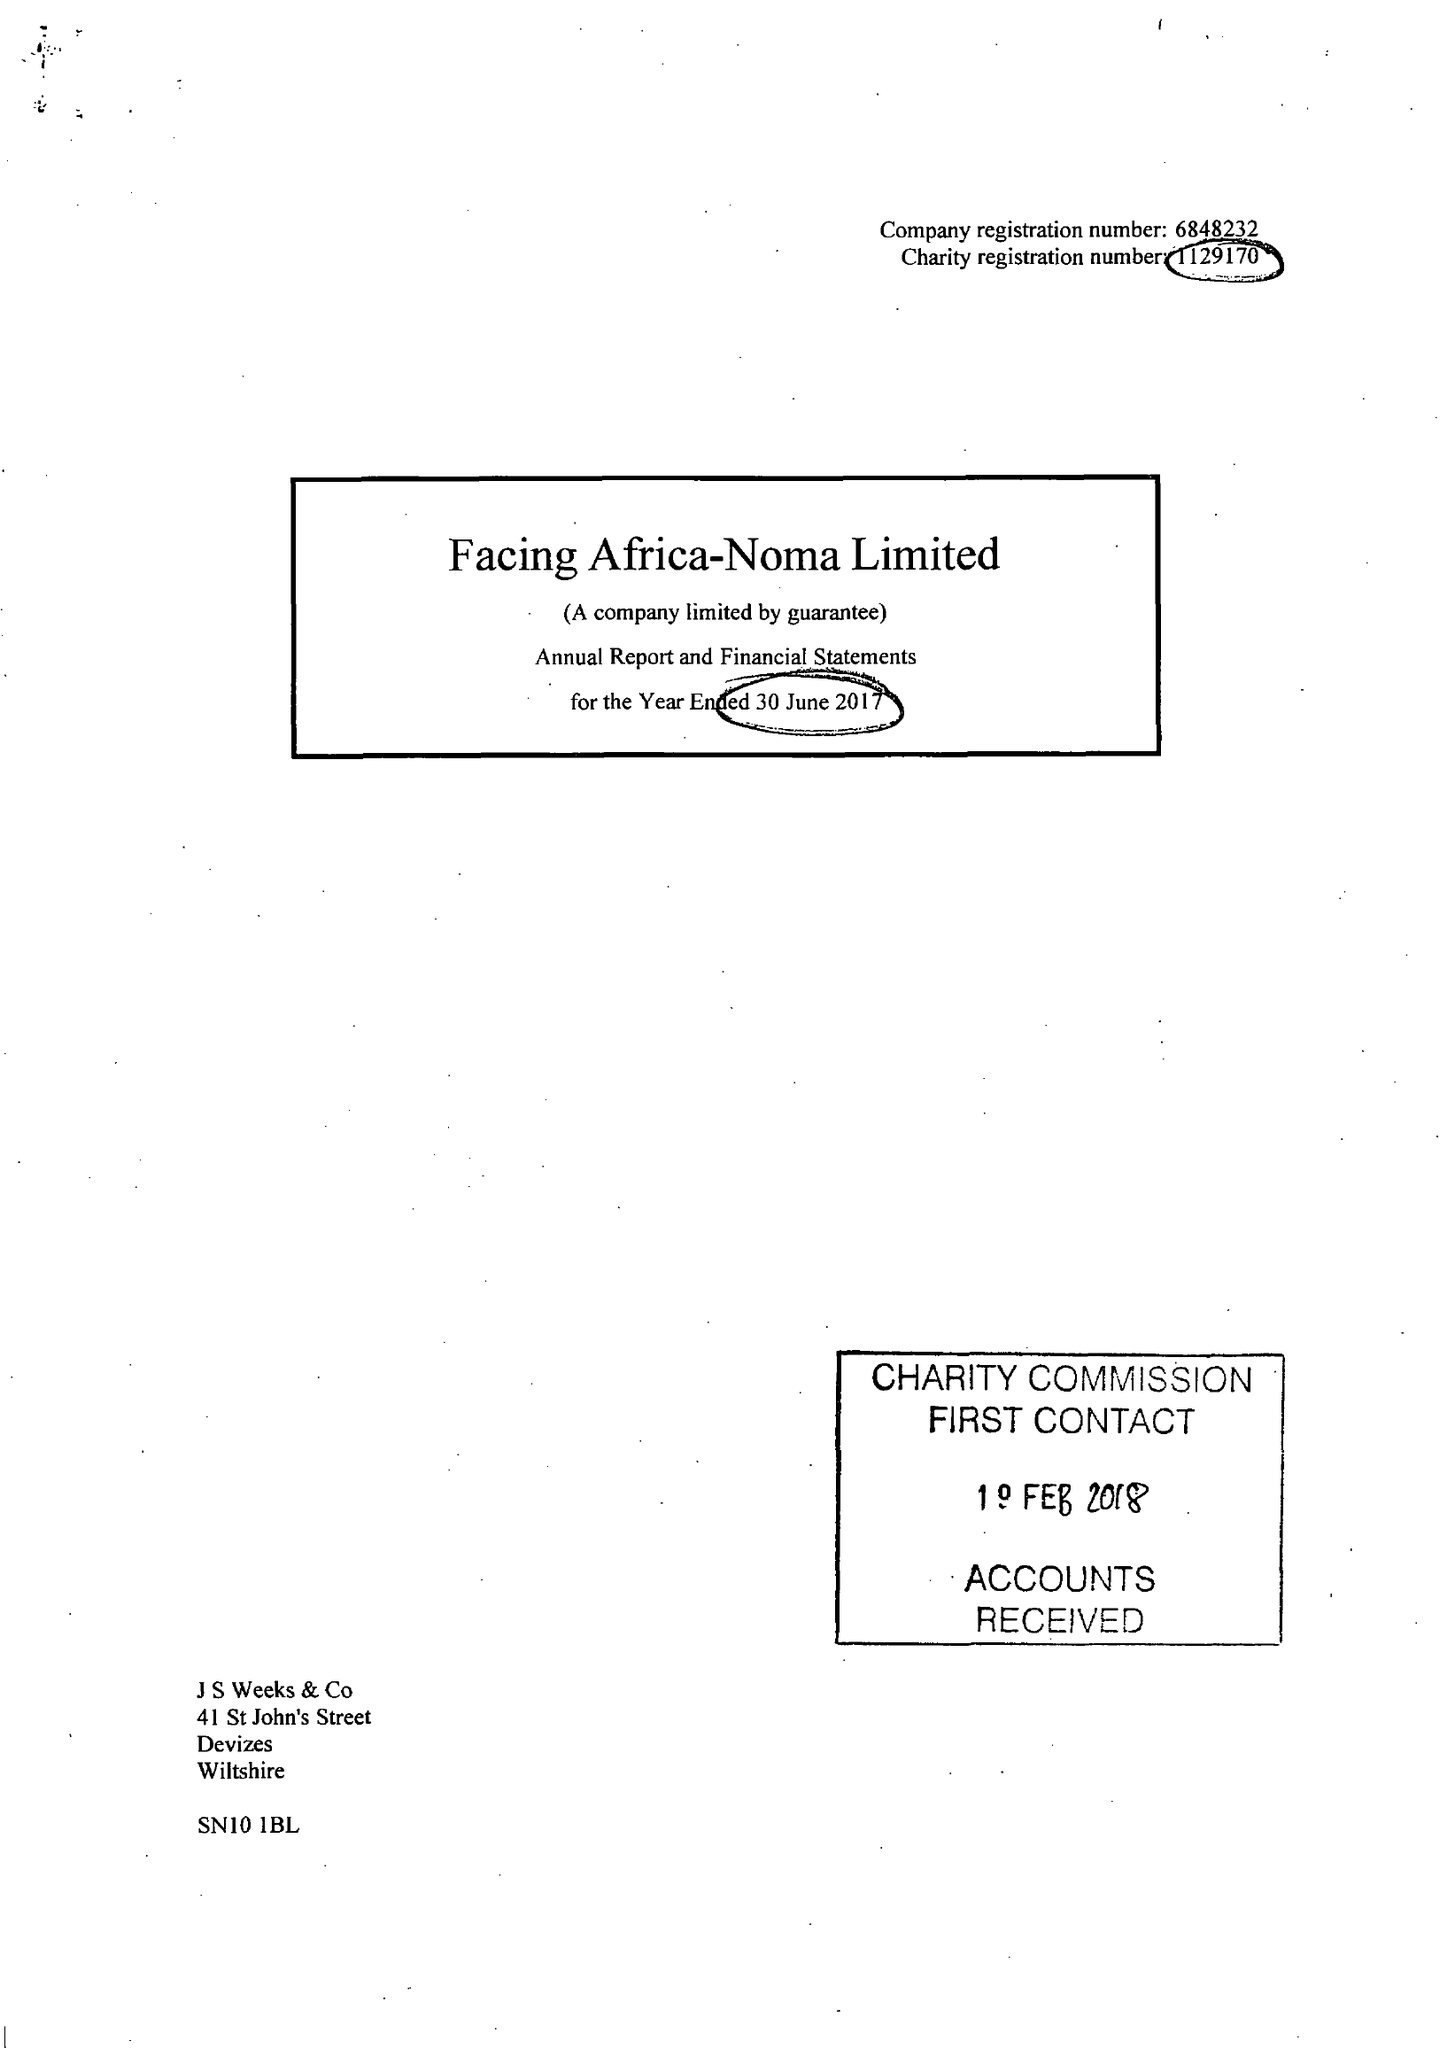What is the value for the income_annually_in_british_pounds?
Answer the question using a single word or phrase. 142489.00 